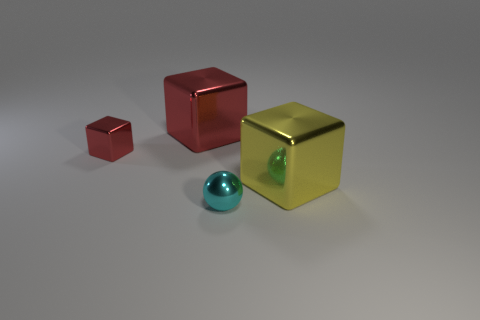Add 4 tiny purple cubes. How many objects exist? 8 Subtract all yellow cylinders. How many red cubes are left? 2 Subtract all red cubes. How many cubes are left? 1 Subtract all blocks. How many objects are left? 1 Add 1 red shiny cubes. How many red shiny cubes exist? 3 Subtract all yellow blocks. How many blocks are left? 2 Subtract 0 gray balls. How many objects are left? 4 Subtract all green spheres. Subtract all green blocks. How many spheres are left? 1 Subtract all yellow metallic objects. Subtract all metal blocks. How many objects are left? 0 Add 2 red metallic things. How many red metallic things are left? 4 